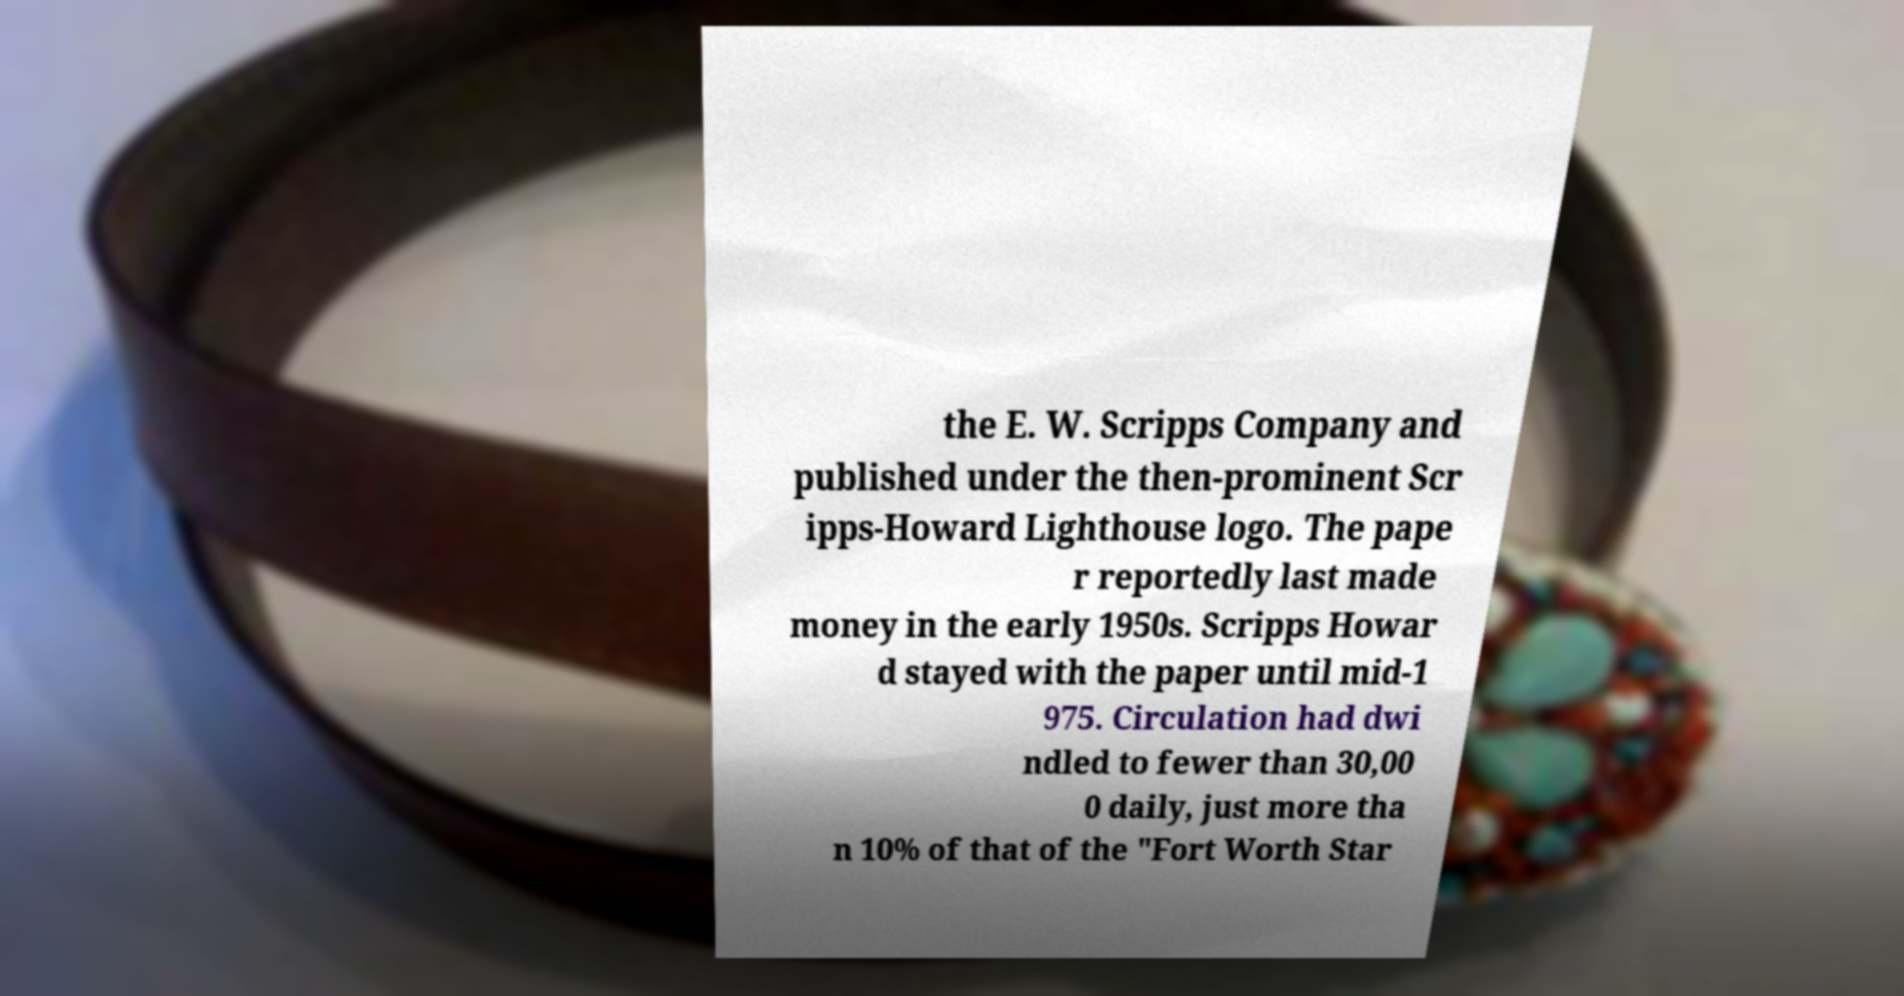Please read and relay the text visible in this image. What does it say? the E. W. Scripps Company and published under the then-prominent Scr ipps-Howard Lighthouse logo. The pape r reportedly last made money in the early 1950s. Scripps Howar d stayed with the paper until mid-1 975. Circulation had dwi ndled to fewer than 30,00 0 daily, just more tha n 10% of that of the "Fort Worth Star 